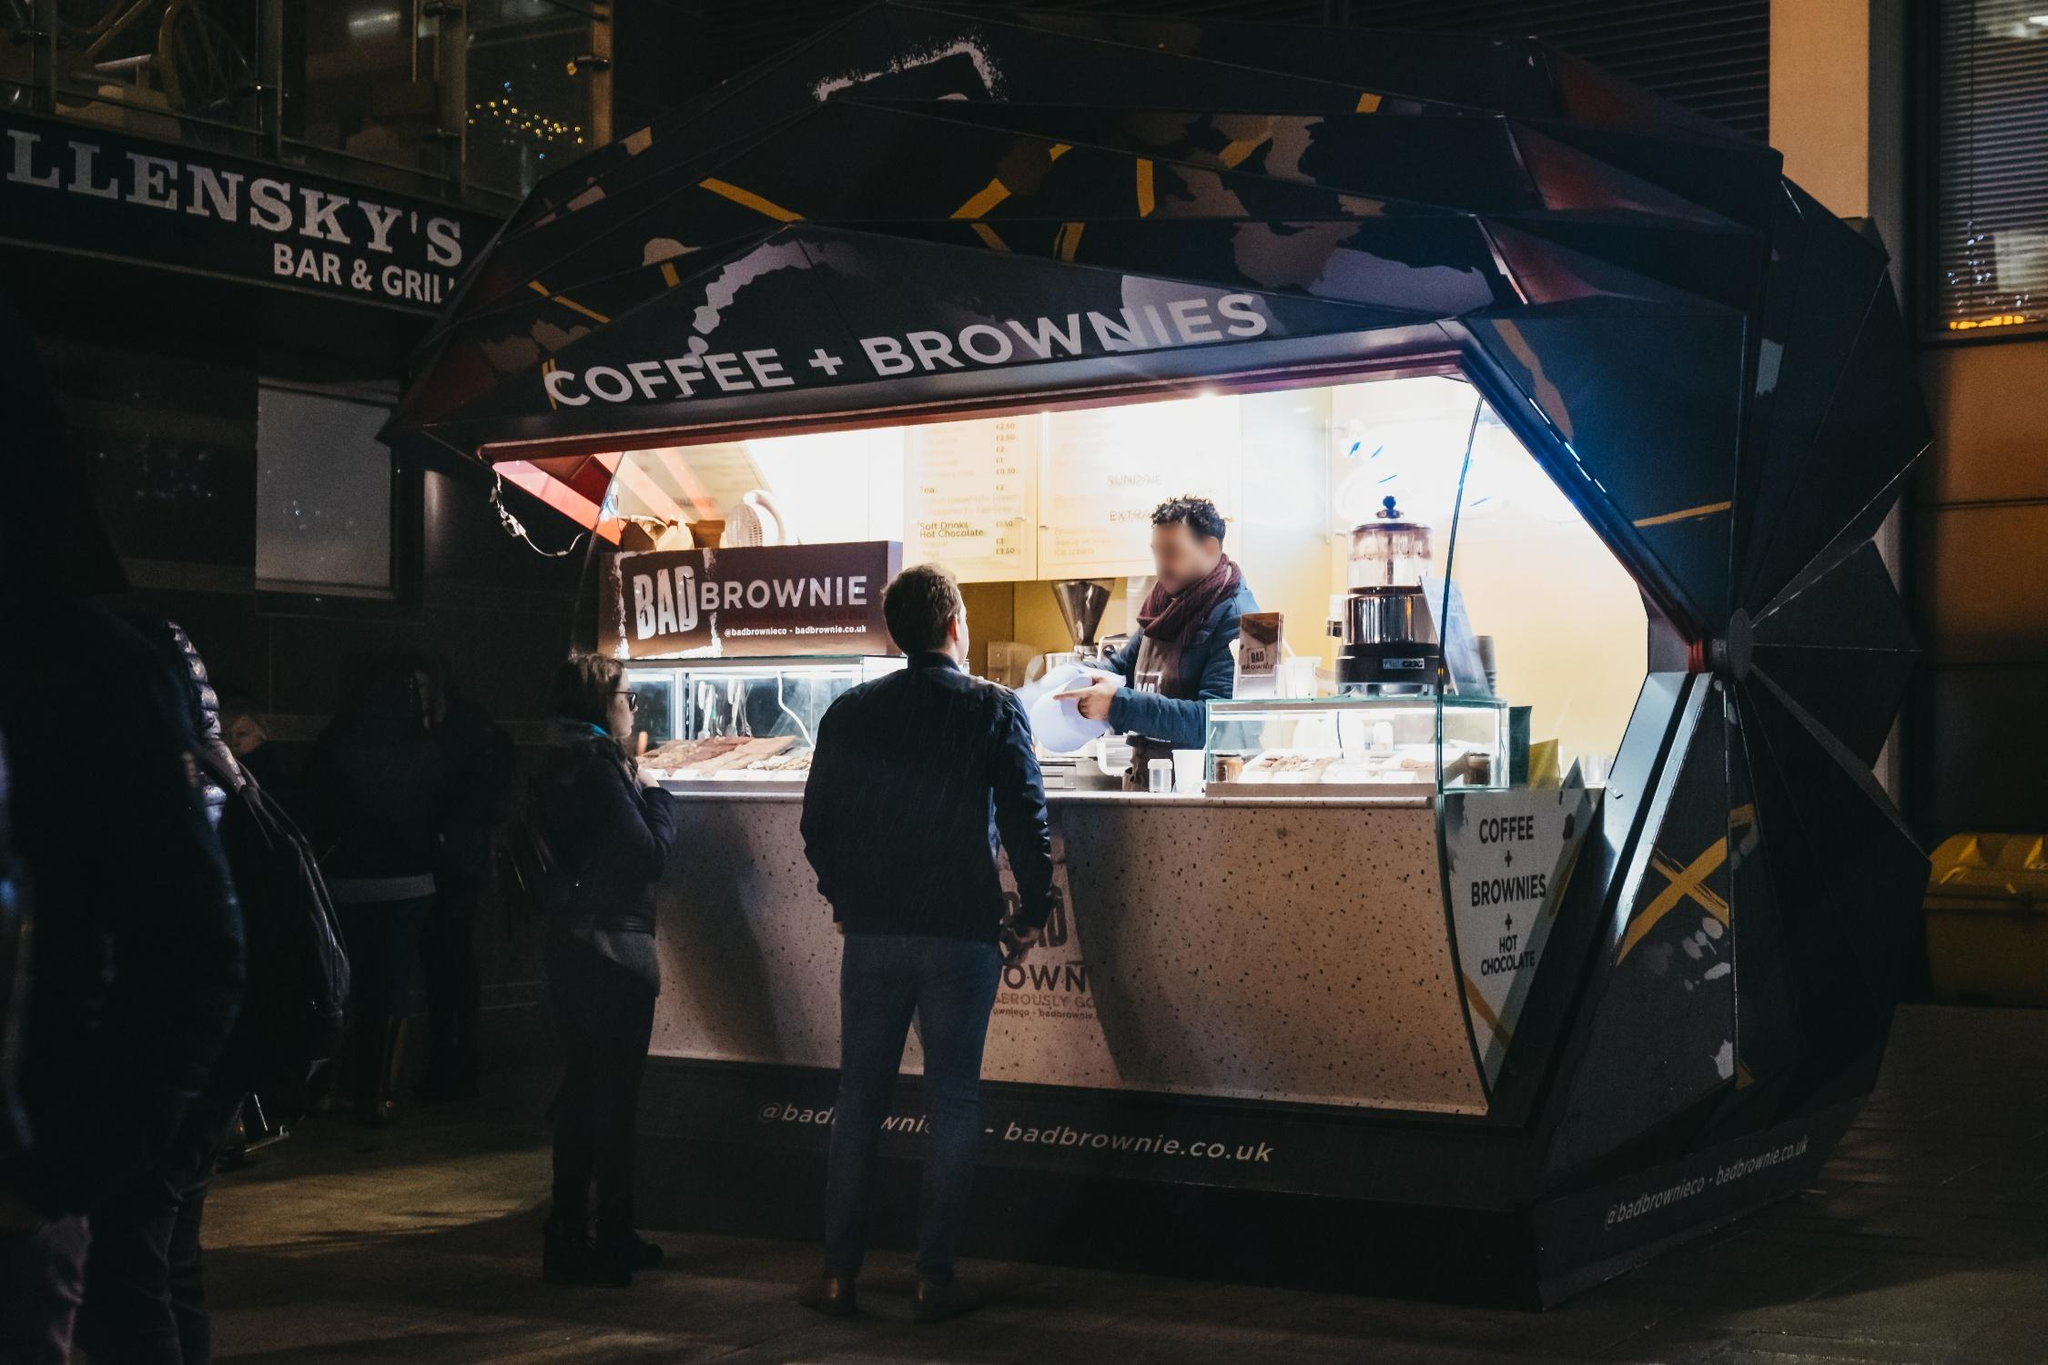Can you tell me about the varieties of brownies available at this stall? The 'BADBROWNIE' stall offers a tempting range of brownie choices, which seem to include both classic and unique flavors. The visible menu hints at varieties likely ranging from the decadent double chocolate to perhaps a salted caramel or a cheeky chili chocolate, each promising a rich, indulgent experience typical of gourmet brownies. Which one seems to be the most popular with customers tonight? Judging by the interactions and selections visible at the counter, the classic double chocolate seems to be a firm favorite, with several customers seen holding pieces that exhibit its dense, dark texture. It’s a classic choice that rarely disappoints the palates of brownie enthusiasts. 